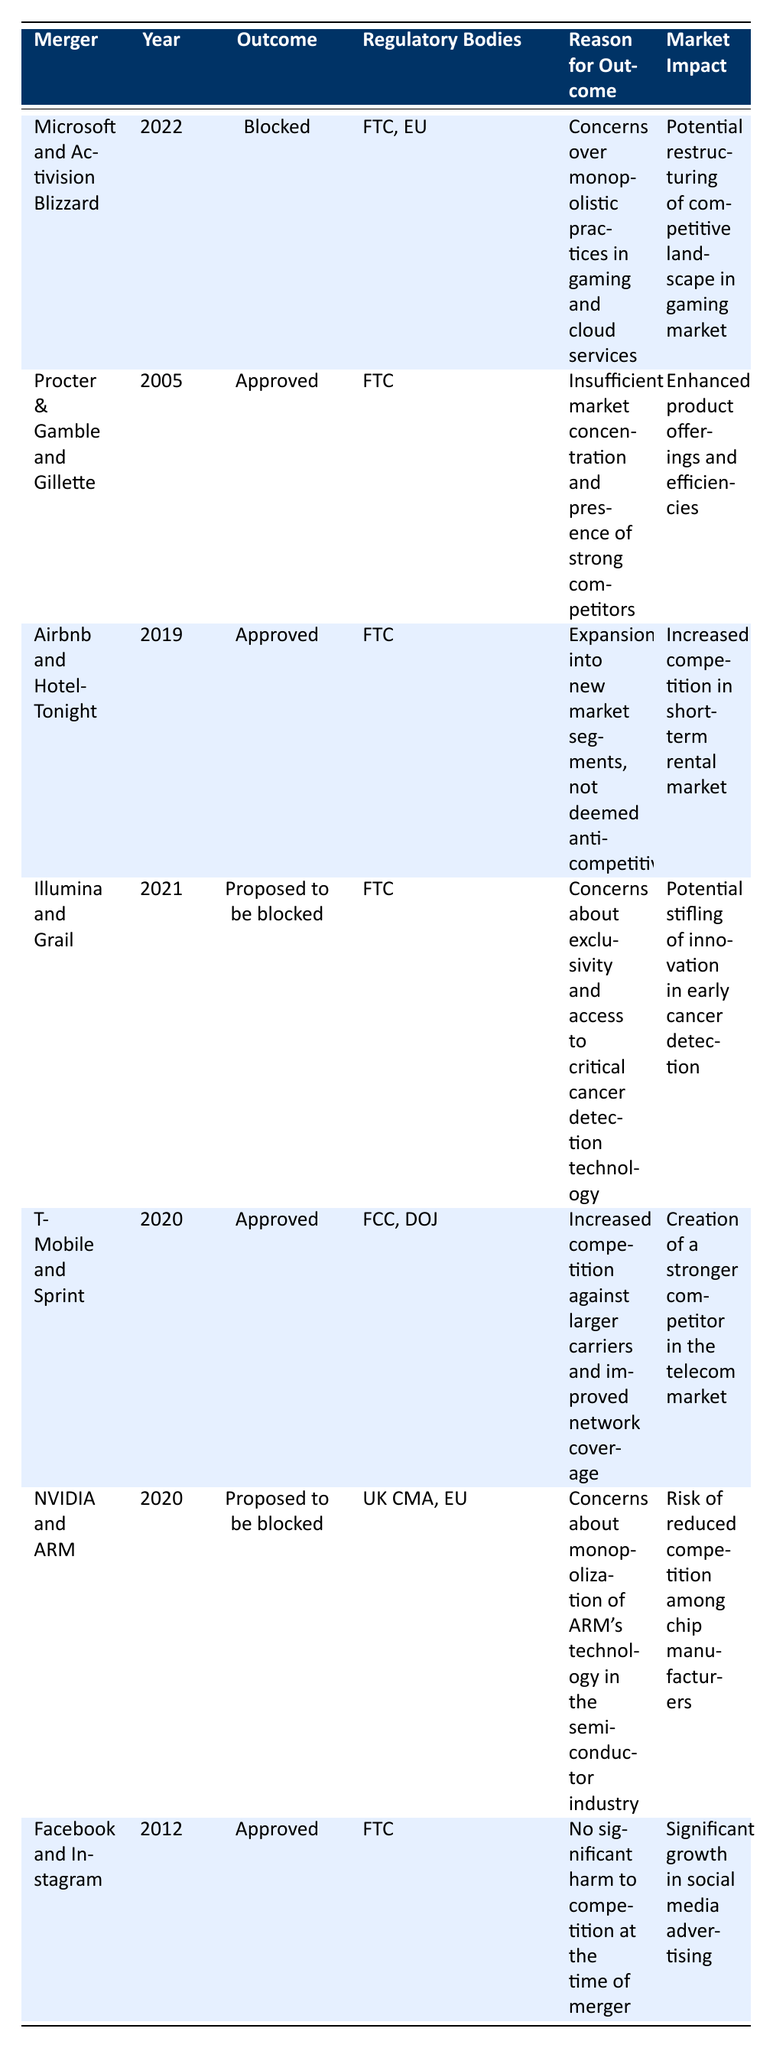What was the outcome of the Microsoft and Activision Blizzard merger? The table lists the outcome for the Microsoft and Activision Blizzard merger as "Blocked." I found this information in the "Outcome" column corresponding to that merger.
Answer: Blocked Which regulatory bodies were involved in the T-Mobile and Sprint merger? The table indicates that the regulatory bodies for the T-Mobile and Sprint merger were the FCC and DOJ. This information can be located in the "Regulatory Bodies" column for that entry.
Answer: FCC, DOJ How many mergers were blocked in the provided data? Referring to the "Outcome" column, I can see that two mergers were proposed to be blocked (Microsoft and Activision Blizzard, NVIDIA and ARM) and one was actually blocked. Therefore, 1 merger was completed as blocked.
Answer: 1 What concerns did regulators have about the Illumina and Grail merger? The table states that the reason for the proposed blockage of the Illumina and Grail merger was concerns about exclusivity and access to critical cancer detection technology. This is found in the "Reason for Outcome" column for this merger.
Answer: Concerns about exclusivity and access to critical cancer detection technology Was there any merger that resulted in enhanced product offerings and efficiencies? According to the table, the Procter & Gamble and Gillette merger, which was approved, resulted in enhanced product offerings and efficiencies. This specific detail is derived from the "Market Impact" column for that merger.
Answer: Yes Which merger had the year 2020 and what was its outcome? The T-Mobile and Sprint merger occurred in 2020 and it was approved. This information is gathered from the "Year" and "Outcome" columns for that specific entry.
Answer: T-Mobile and Sprint; Approved What is the market impact of the merger between Facebook and Instagram? The table states that the market impact of the Facebook and Instagram merger was significant growth in social media advertising. This can be confirmed by checking the "Market Impact" column corresponding to that merger entry.
Answer: Significant growth in social media advertising Among the listed mergers, which had the regulatory bodies FTC, EU involved and what was the outcome? Looking at the table, the Microsoft and Activision Blizzard merger had the regulatory bodies FTC and EU involved, and its outcome was blocked. This information is extracted from the respective columns for that merger.
Answer: Blocked How many mergers were approved in 2019? The table indicates that one merger, the Airbnb and HotelTonight merger, was approved in 2019. This is deduced by cross-referencing the "Year" and "Outcome" columns to identify the relevant entry.
Answer: 1 